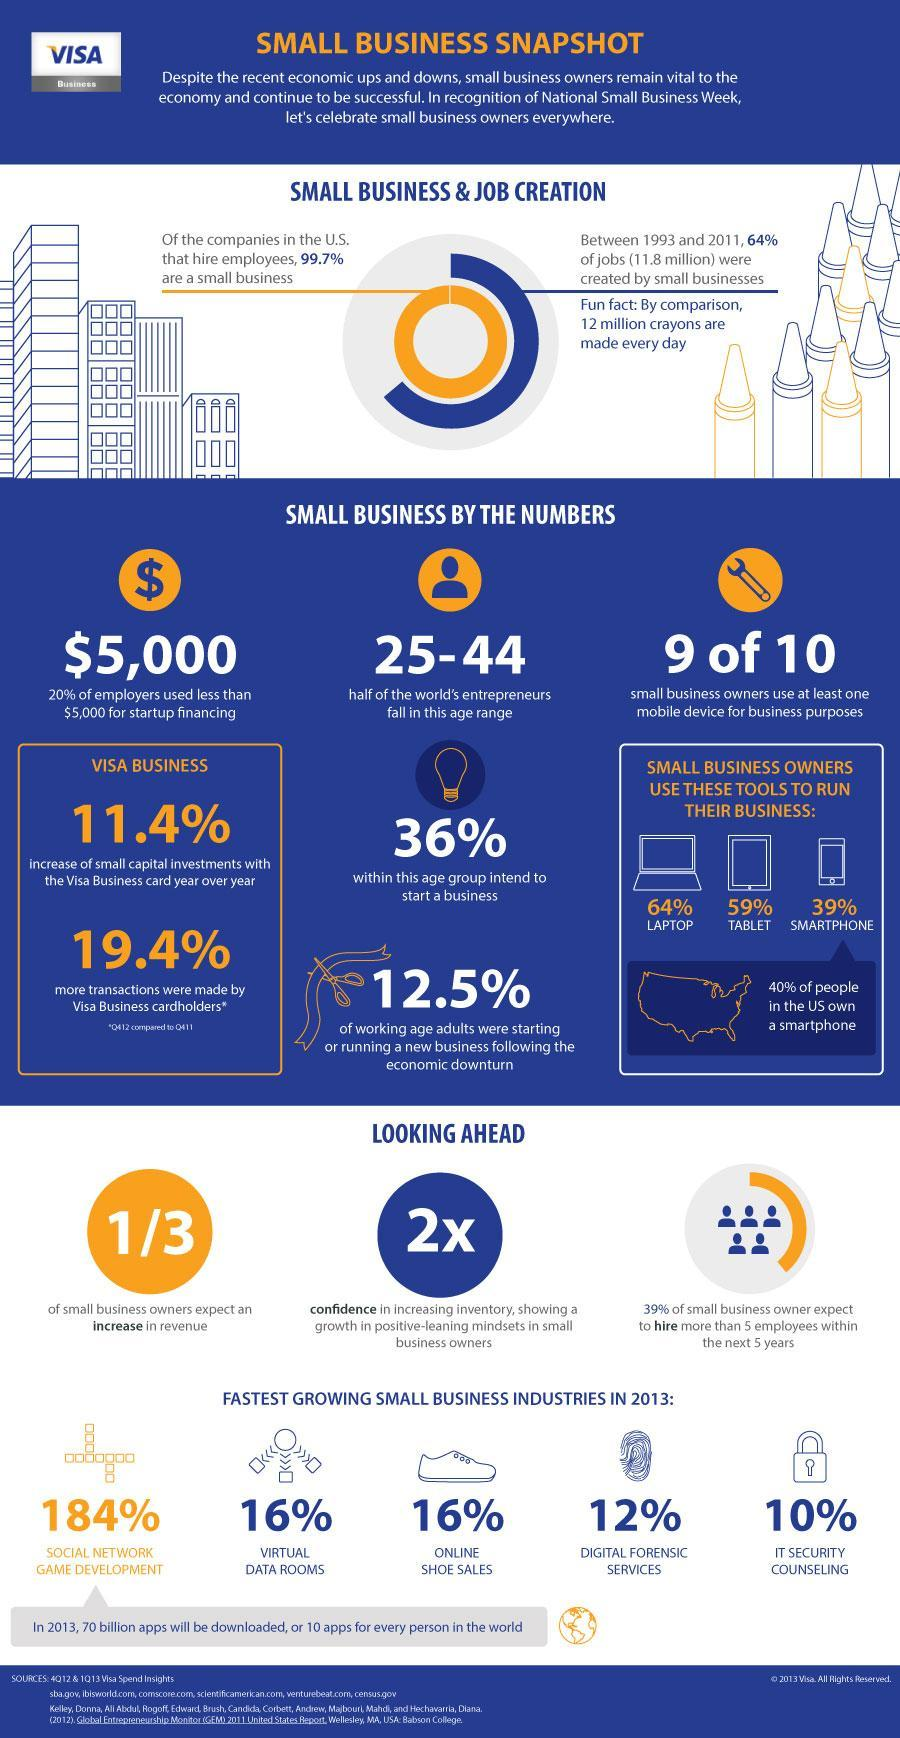What percentage of people in the  US town didn't own a smartphone?
Answer the question with a short phrase. 60% What is the percentage growth of IT security counseling? 10% What is the percentage growth of online shoe sales business? 16% What is the percentage growth of digital forensic services? 12% What percentage of working-age adults have not started a new business? 87.5% What is the percentage growth of social network game development? 184% What is the percentage growth of virtual data room business? 16% How many fast-growing industries in the year 2013 mentioned in this infographic? 5 